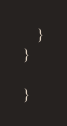<code> <loc_0><loc_0><loc_500><loc_500><_C++_>    }
}

}

</code> 